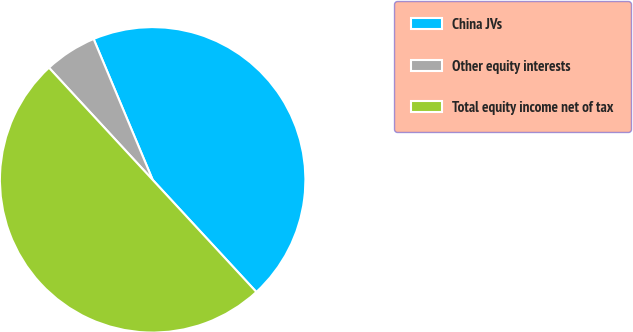Convert chart. <chart><loc_0><loc_0><loc_500><loc_500><pie_chart><fcel>China JVs<fcel>Other equity interests<fcel>Total equity income net of tax<nl><fcel>44.44%<fcel>5.56%<fcel>50.0%<nl></chart> 